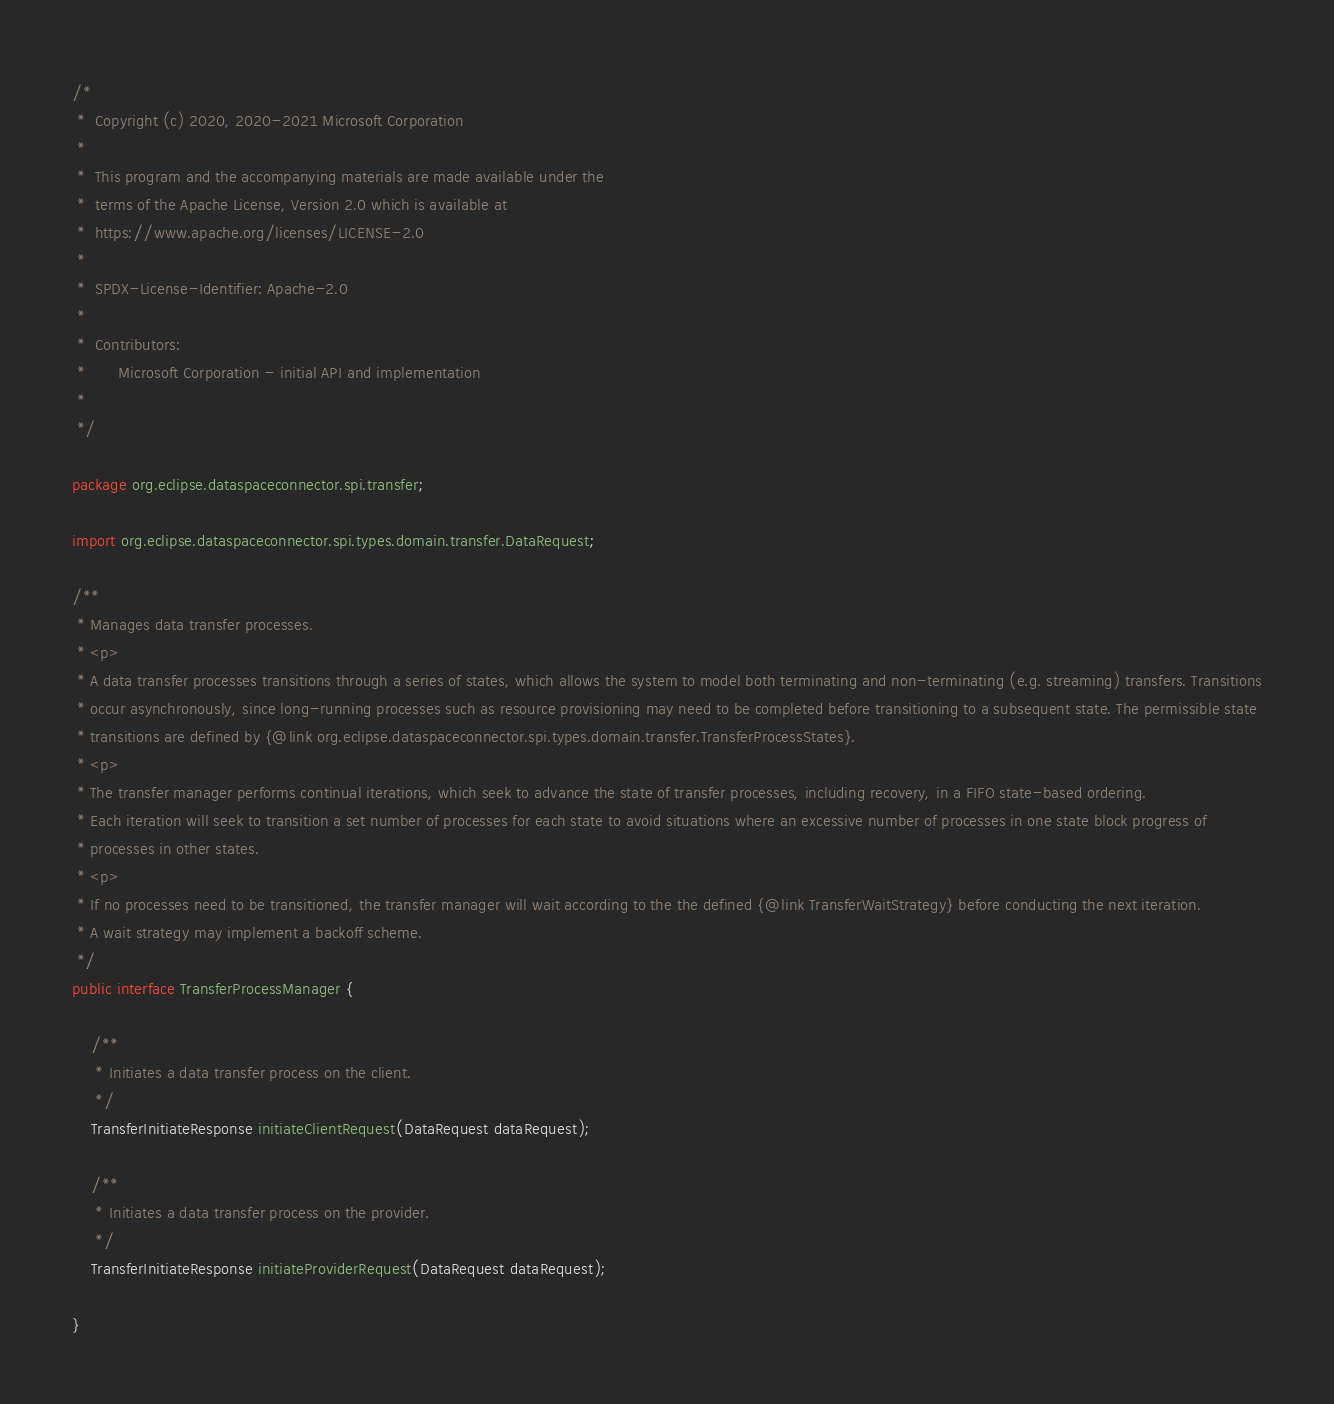<code> <loc_0><loc_0><loc_500><loc_500><_Java_>/*
 *  Copyright (c) 2020, 2020-2021 Microsoft Corporation
 *
 *  This program and the accompanying materials are made available under the
 *  terms of the Apache License, Version 2.0 which is available at
 *  https://www.apache.org/licenses/LICENSE-2.0
 *
 *  SPDX-License-Identifier: Apache-2.0
 *
 *  Contributors:
 *       Microsoft Corporation - initial API and implementation
 *
 */

package org.eclipse.dataspaceconnector.spi.transfer;

import org.eclipse.dataspaceconnector.spi.types.domain.transfer.DataRequest;

/**
 * Manages data transfer processes.
 * <p>
 * A data transfer processes transitions through a series of states, which allows the system to model both terminating and non-terminating (e.g. streaming) transfers. Transitions
 * occur asynchronously, since long-running processes such as resource provisioning may need to be completed before transitioning to a subsequent state. The permissible state
 * transitions are defined by {@link org.eclipse.dataspaceconnector.spi.types.domain.transfer.TransferProcessStates}.
 * <p>
 * The transfer manager performs continual iterations, which seek to advance the state of transfer processes, including recovery, in a FIFO state-based ordering.
 * Each iteration will seek to transition a set number of processes for each state to avoid situations where an excessive number of processes in one state block progress of
 * processes in other states.
 * <p>
 * If no processes need to be transitioned, the transfer manager will wait according to the the defined {@link TransferWaitStrategy} before conducting the next iteration.
 * A wait strategy may implement a backoff scheme.
 */
public interface TransferProcessManager {

    /**
     * Initiates a data transfer process on the client.
     */
    TransferInitiateResponse initiateClientRequest(DataRequest dataRequest);

    /**
     * Initiates a data transfer process on the provider.
     */
    TransferInitiateResponse initiateProviderRequest(DataRequest dataRequest);

}
</code> 